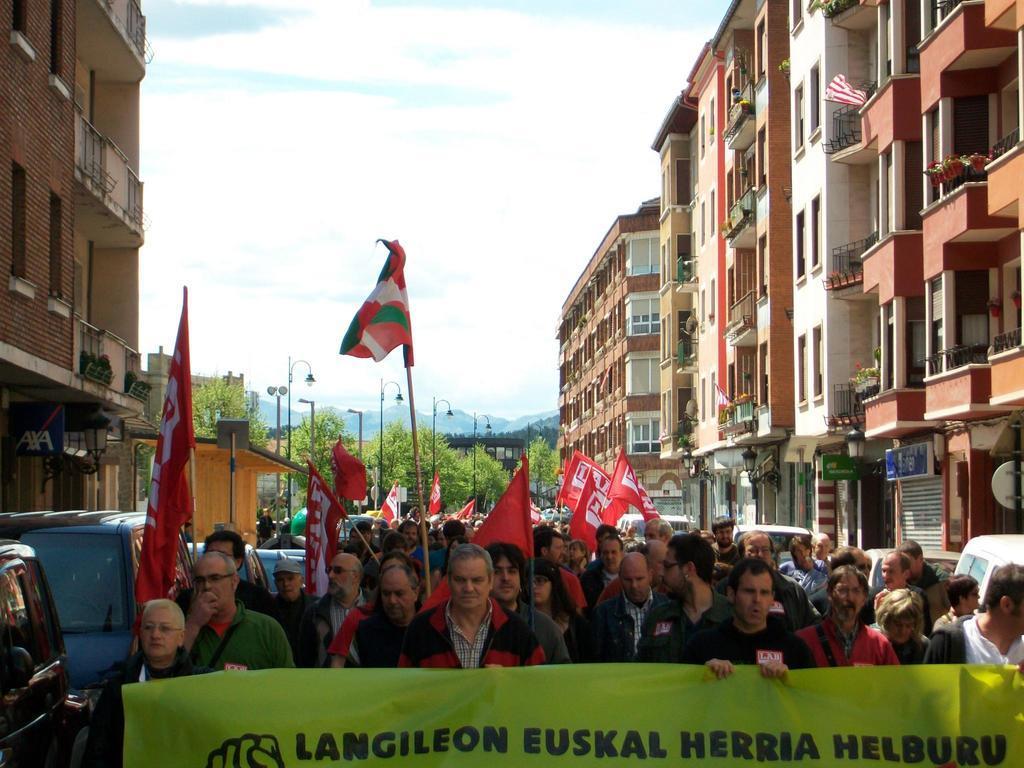How would you summarize this image in a sentence or two? In this picture there are some people walking on the road, holding red color flags in their hands. There are men and women in this picture. We can observe a green color poster here. There are vehicles parked on either sides of the road. We can observe buildings and street light poles. In the background there are trees, hills and a sky with some clouds. 